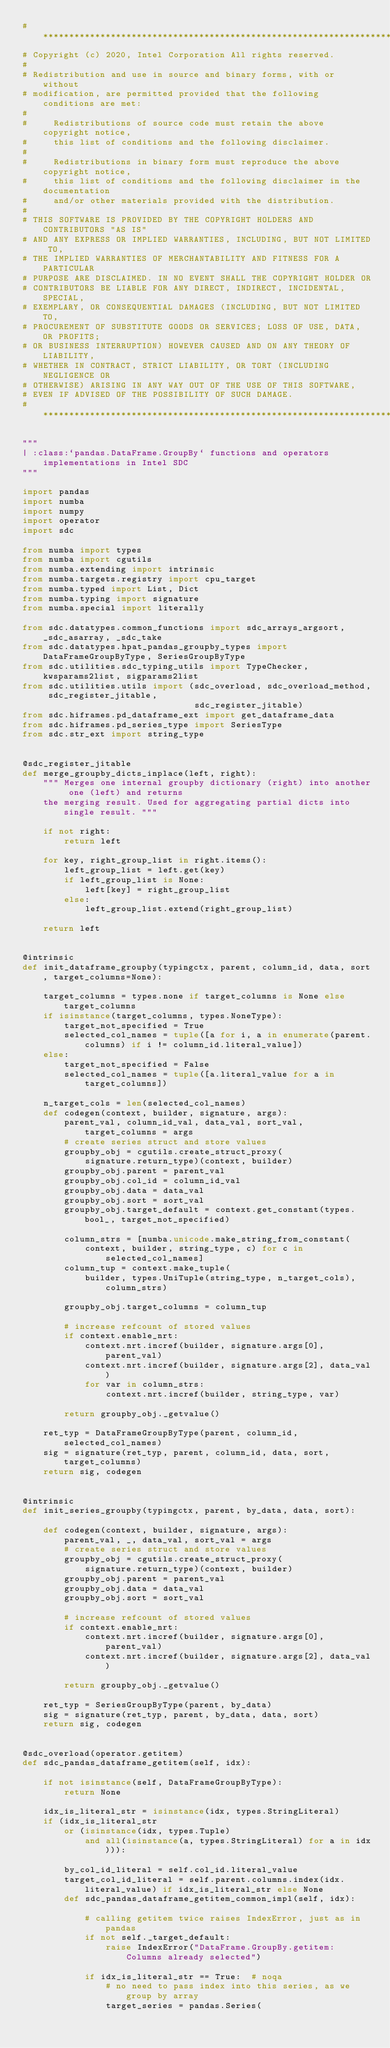<code> <loc_0><loc_0><loc_500><loc_500><_Python_># *****************************************************************************
# Copyright (c) 2020, Intel Corporation All rights reserved.
#
# Redistribution and use in source and binary forms, with or without
# modification, are permitted provided that the following conditions are met:
#
#     Redistributions of source code must retain the above copyright notice,
#     this list of conditions and the following disclaimer.
#
#     Redistributions in binary form must reproduce the above copyright notice,
#     this list of conditions and the following disclaimer in the documentation
#     and/or other materials provided with the distribution.
#
# THIS SOFTWARE IS PROVIDED BY THE COPYRIGHT HOLDERS AND CONTRIBUTORS "AS IS"
# AND ANY EXPRESS OR IMPLIED WARRANTIES, INCLUDING, BUT NOT LIMITED TO,
# THE IMPLIED WARRANTIES OF MERCHANTABILITY AND FITNESS FOR A PARTICULAR
# PURPOSE ARE DISCLAIMED. IN NO EVENT SHALL THE COPYRIGHT HOLDER OR
# CONTRIBUTORS BE LIABLE FOR ANY DIRECT, INDIRECT, INCIDENTAL, SPECIAL,
# EXEMPLARY, OR CONSEQUENTIAL DAMAGES (INCLUDING, BUT NOT LIMITED TO,
# PROCUREMENT OF SUBSTITUTE GOODS OR SERVICES; LOSS OF USE, DATA, OR PROFITS;
# OR BUSINESS INTERRUPTION) HOWEVER CAUSED AND ON ANY THEORY OF LIABILITY,
# WHETHER IN CONTRACT, STRICT LIABILITY, OR TORT (INCLUDING NEGLIGENCE OR
# OTHERWISE) ARISING IN ANY WAY OUT OF THE USE OF THIS SOFTWARE,
# EVEN IF ADVISED OF THE POSSIBILITY OF SUCH DAMAGE.
# *****************************************************************************

"""
| :class:`pandas.DataFrame.GroupBy` functions and operators implementations in Intel SDC
"""

import pandas
import numba
import numpy
import operator
import sdc

from numba import types
from numba import cgutils
from numba.extending import intrinsic
from numba.targets.registry import cpu_target
from numba.typed import List, Dict
from numba.typing import signature
from numba.special import literally

from sdc.datatypes.common_functions import sdc_arrays_argsort, _sdc_asarray, _sdc_take
from sdc.datatypes.hpat_pandas_groupby_types import DataFrameGroupByType, SeriesGroupByType
from sdc.utilities.sdc_typing_utils import TypeChecker, kwsparams2list, sigparams2list
from sdc.utilities.utils import (sdc_overload, sdc_overload_method, sdc_register_jitable,
                                 sdc_register_jitable)
from sdc.hiframes.pd_dataframe_ext import get_dataframe_data
from sdc.hiframes.pd_series_type import SeriesType
from sdc.str_ext import string_type


@sdc_register_jitable
def merge_groupby_dicts_inplace(left, right):
    """ Merges one internal groupby dictionary (right) into another one (left) and returns
    the merging result. Used for aggregating partial dicts into single result. """

    if not right:
        return left

    for key, right_group_list in right.items():
        left_group_list = left.get(key)
        if left_group_list is None:
            left[key] = right_group_list
        else:
            left_group_list.extend(right_group_list)

    return left


@intrinsic
def init_dataframe_groupby(typingctx, parent, column_id, data, sort, target_columns=None):

    target_columns = types.none if target_columns is None else target_columns
    if isinstance(target_columns, types.NoneType):
        target_not_specified = True
        selected_col_names = tuple([a for i, a in enumerate(parent.columns) if i != column_id.literal_value])
    else:
        target_not_specified = False
        selected_col_names = tuple([a.literal_value for a in target_columns])

    n_target_cols = len(selected_col_names)
    def codegen(context, builder, signature, args):
        parent_val, column_id_val, data_val, sort_val, target_columns = args
        # create series struct and store values
        groupby_obj = cgutils.create_struct_proxy(
            signature.return_type)(context, builder)
        groupby_obj.parent = parent_val
        groupby_obj.col_id = column_id_val
        groupby_obj.data = data_val
        groupby_obj.sort = sort_val
        groupby_obj.target_default = context.get_constant(types.bool_, target_not_specified)

        column_strs = [numba.unicode.make_string_from_constant(
            context, builder, string_type, c) for c in selected_col_names]
        column_tup = context.make_tuple(
            builder, types.UniTuple(string_type, n_target_cols), column_strs)

        groupby_obj.target_columns = column_tup

        # increase refcount of stored values
        if context.enable_nrt:
            context.nrt.incref(builder, signature.args[0], parent_val)
            context.nrt.incref(builder, signature.args[2], data_val)
            for var in column_strs:
                context.nrt.incref(builder, string_type, var)

        return groupby_obj._getvalue()

    ret_typ = DataFrameGroupByType(parent, column_id, selected_col_names)
    sig = signature(ret_typ, parent, column_id, data, sort, target_columns)
    return sig, codegen


@intrinsic
def init_series_groupby(typingctx, parent, by_data, data, sort):

    def codegen(context, builder, signature, args):
        parent_val, _, data_val, sort_val = args
        # create series struct and store values
        groupby_obj = cgutils.create_struct_proxy(
            signature.return_type)(context, builder)
        groupby_obj.parent = parent_val
        groupby_obj.data = data_val
        groupby_obj.sort = sort_val

        # increase refcount of stored values
        if context.enable_nrt:
            context.nrt.incref(builder, signature.args[0], parent_val)
            context.nrt.incref(builder, signature.args[2], data_val)

        return groupby_obj._getvalue()

    ret_typ = SeriesGroupByType(parent, by_data)
    sig = signature(ret_typ, parent, by_data, data, sort)
    return sig, codegen


@sdc_overload(operator.getitem)
def sdc_pandas_dataframe_getitem(self, idx):

    if not isinstance(self, DataFrameGroupByType):
        return None

    idx_is_literal_str = isinstance(idx, types.StringLiteral)
    if (idx_is_literal_str
        or (isinstance(idx, types.Tuple)
            and all(isinstance(a, types.StringLiteral) for a in idx))):

        by_col_id_literal = self.col_id.literal_value
        target_col_id_literal = self.parent.columns.index(idx.literal_value) if idx_is_literal_str else None
        def sdc_pandas_dataframe_getitem_common_impl(self, idx):

            # calling getitem twice raises IndexError, just as in pandas
            if not self._target_default:
                raise IndexError("DataFrame.GroupBy.getitem: Columns already selected")

            if idx_is_literal_str == True:  # noqa
                # no need to pass index into this series, as we group by array
                target_series = pandas.Series(</code> 